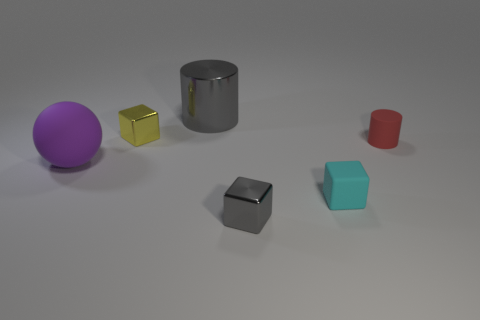What lighting conditions are suggested by the shadows in the scene? The shadows cast in the scene are soft and stretch towards the bottom right, indicating that there is a diffused light source coming from the top left. The lack of sharp edges on the shadows suggests an environment with ambient lighting, possibly from an overcast sky or a soft box light in a studio. 